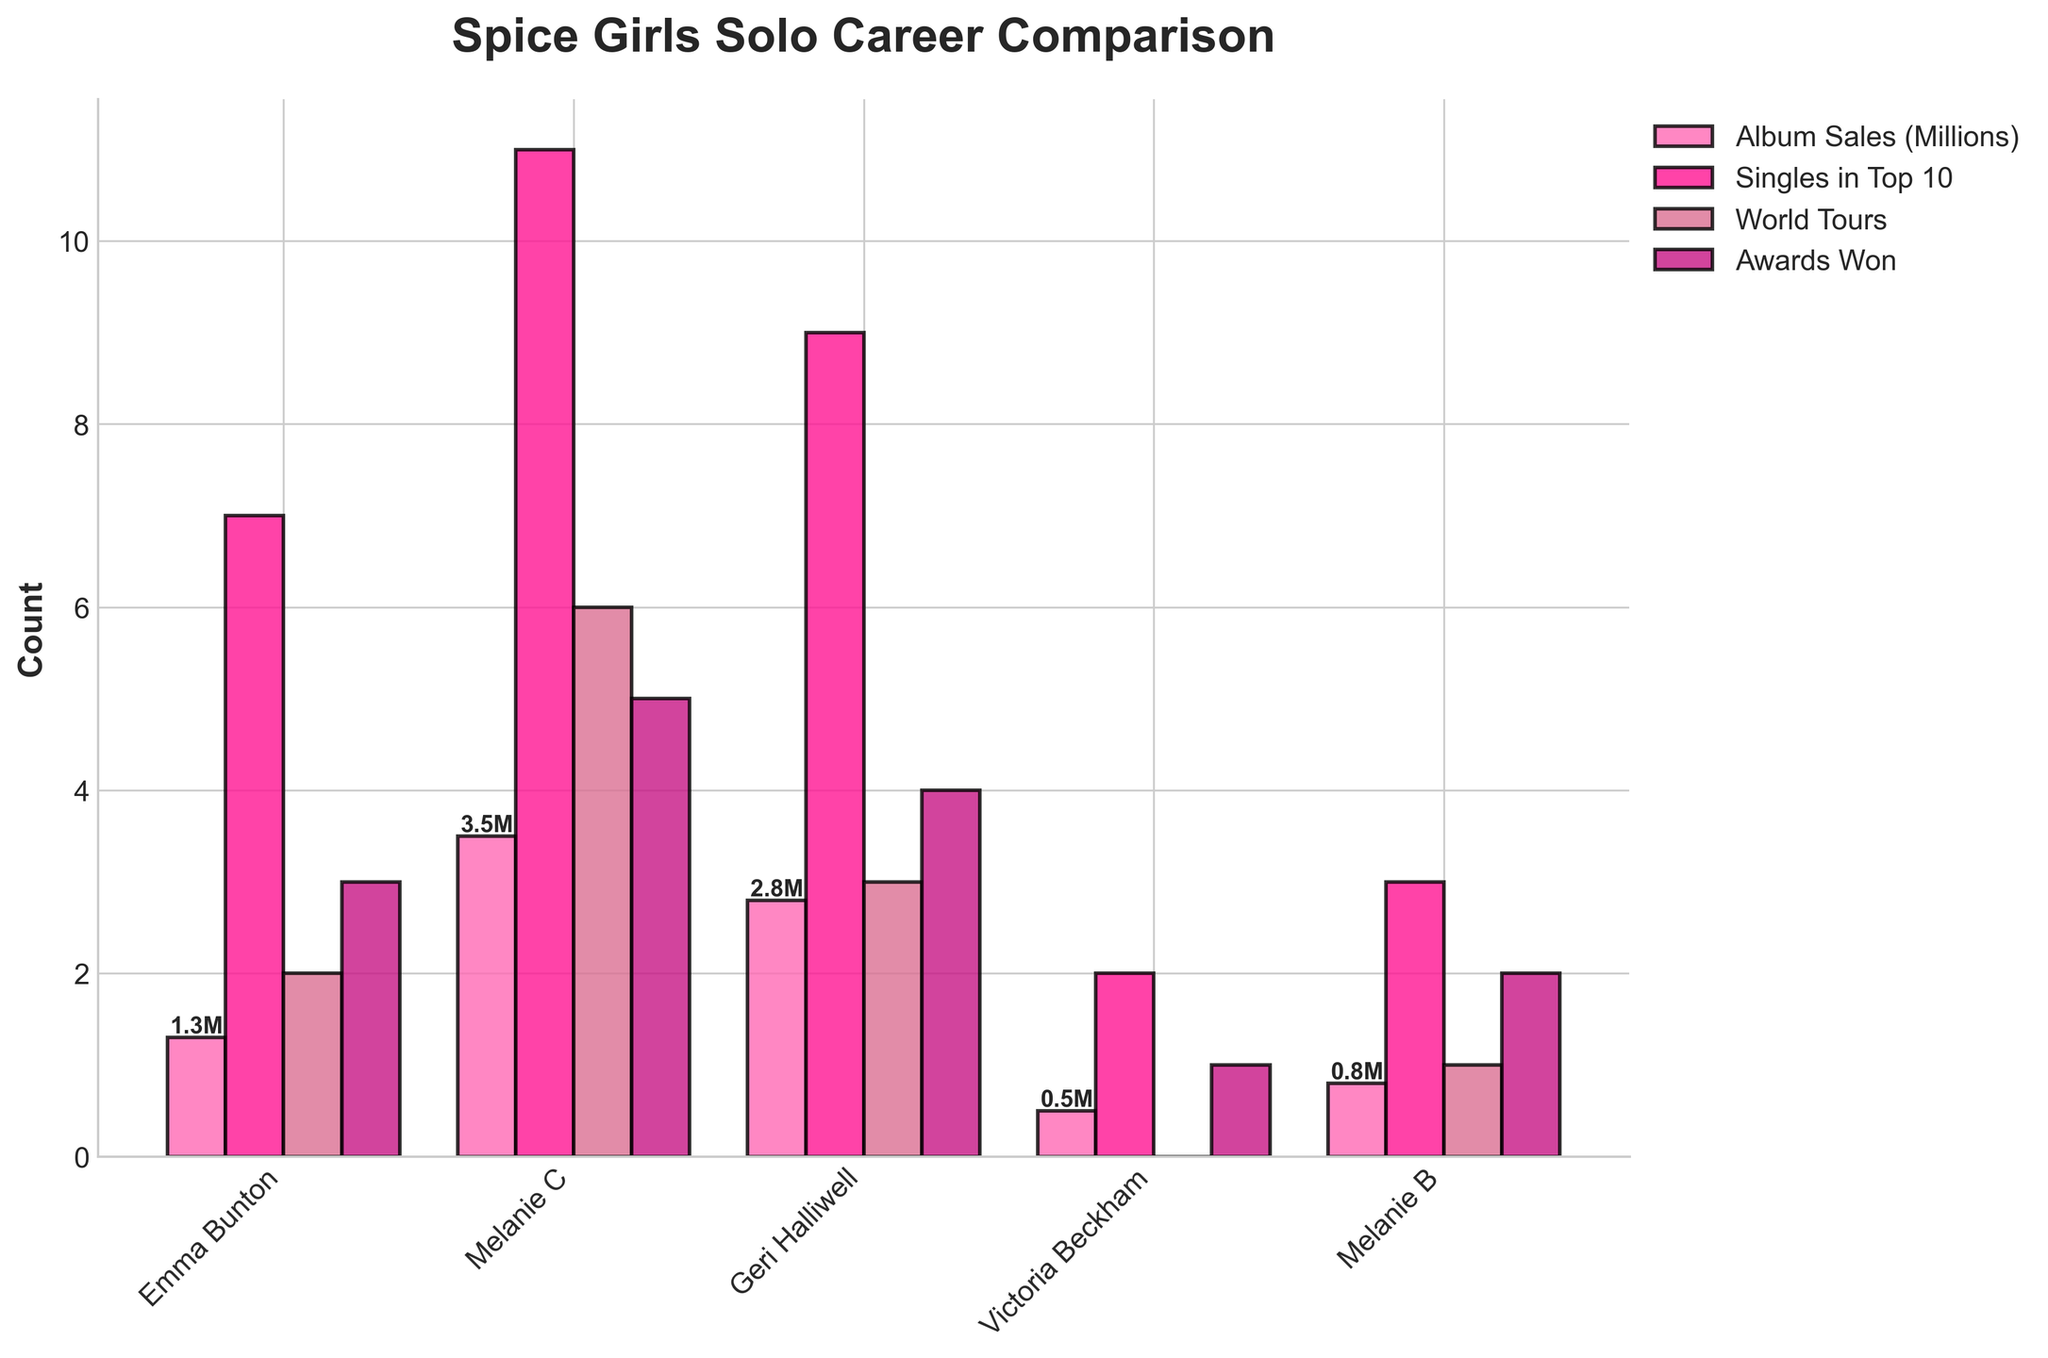Which artist had the highest number of singles in the Top 10? By looking at the bars labeled "Singles in Top 10," we observe that Melanie C's bar is the tallest, indicating she had the most singles in the Top 10.
Answer: Melanie C How many world tours combined did Emma Bunton and Geri Halliwell have? Emma Bunton had 2 world tours, and Geri Halliwell had 3 world tours. Summing these up: 2 + 3 = 5
Answer: 5 Who won the least number of awards? By examining the bars labeled "Awards Won," the shortest bar belongs to Victoria Beckham, indicating she won the least number of awards.
Answer: Victoria Beckham How much higher are Melanie C's album sales compared to Victoria Beckham's? Melanie C's album sales are 3.5 million, and Victoria Beckham's album sales are 0.5 million. Subtracting these, 3.5 - 0.5 = 3
Answer: 3 million Rank the artists based on the number of album sales from highest to lowest. By comparing the bars labeled "Album Sales (Millions)," we get the ranking: Melanie C (3.5M), Geri Halliwell (2.8M), Emma Bunton (1.3M), Melanie B (0.8M), Victoria Beckham (0.5M)
Answer: Melanie C, Geri Halliwell, Emma Bunton, Melanie B, Victoria Beckham Which metric does Emma Bunton score the highest in? Emma Bunton's bars are compared across all metrics. Her highest score is in "Singles in Top 10," where she has 7.
Answer: Singles in Top 10 What is the average number of awards won by the five artists? Summing the awards won (3 + 5 + 4 + 1 + 2 = 15) and dividing by the number of artists (15 / 5 = 3) gives the average number of awards won.
Answer: 3 Who has the least number of World Tours, and how many? By observing the bars labeled "World Tours," Victoria Beckham has the shortest bar, indicating 0 World Tours.
Answer: Victoria Beckham, 0 Compare the total numbers of world tours conducted by all artists combined. Summing all bars labeled "World Tours": 2 (Emma Bunton) + 6 (Melanie C) + 3 (Geri Halliwell) + 0 (Victoria Beckham) + 1 (Melanie B) = 12
Answer: 12 Which artist has the closest number of singles in the Top 10 to Emma Bunton? Emma Bunton has 7 singles in the Top 10. Melanie B has 3, Victoria Beckham has 2, Geri Halliwell has 9, and Melanie C has 11. Geri Halliwell (9) is closest to 7.
Answer: Geri Halliwell 